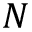Convert formula to latex. <formula><loc_0><loc_0><loc_500><loc_500>N</formula> 